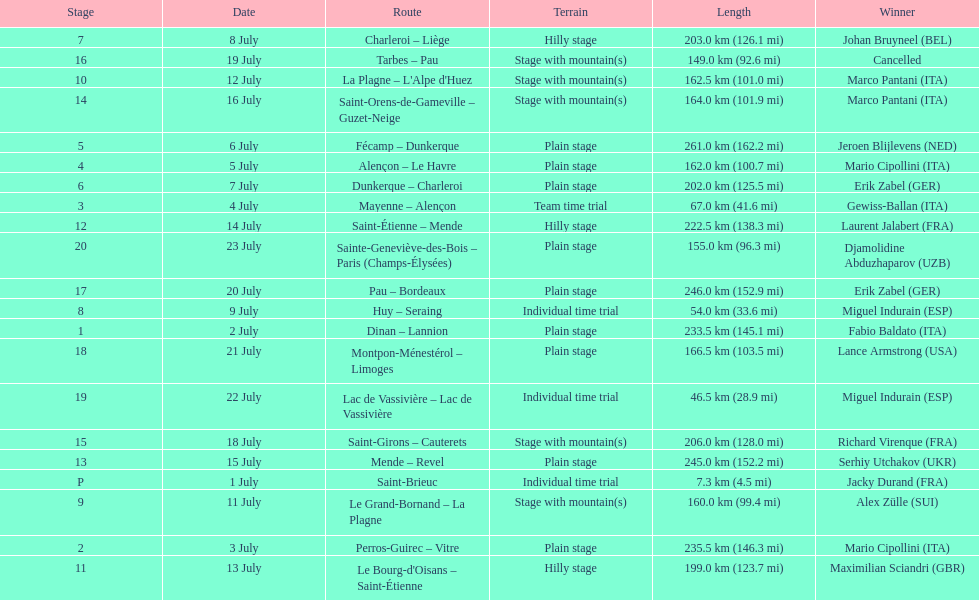What were the dates of the 1995 tour de france? 1 July, 2 July, 3 July, 4 July, 5 July, 6 July, 7 July, 8 July, 9 July, 11 July, 12 July, 13 July, 14 July, 15 July, 16 July, 18 July, 19 July, 20 July, 21 July, 22 July, 23 July. What was the length for july 8th? 203.0 km (126.1 mi). 